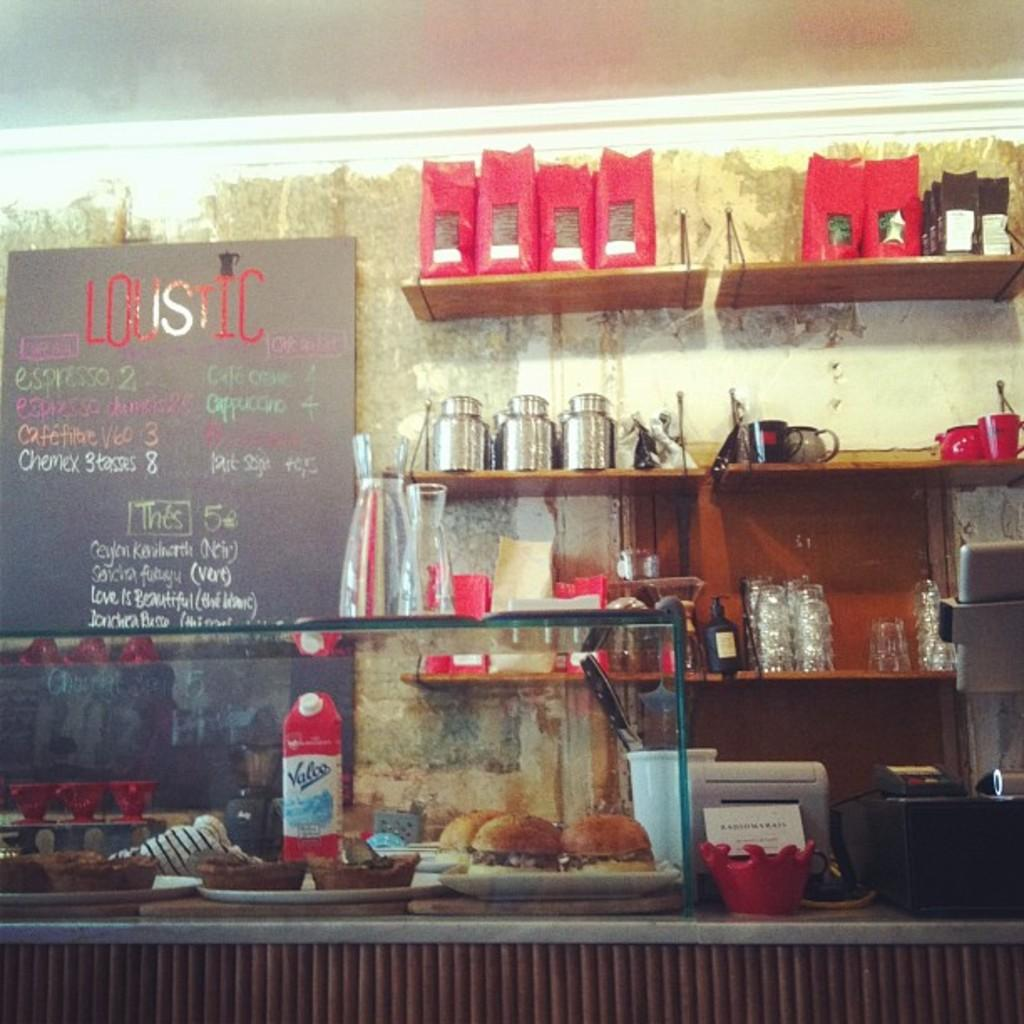<image>
Write a terse but informative summary of the picture. The name on the top of the board is Louistic 